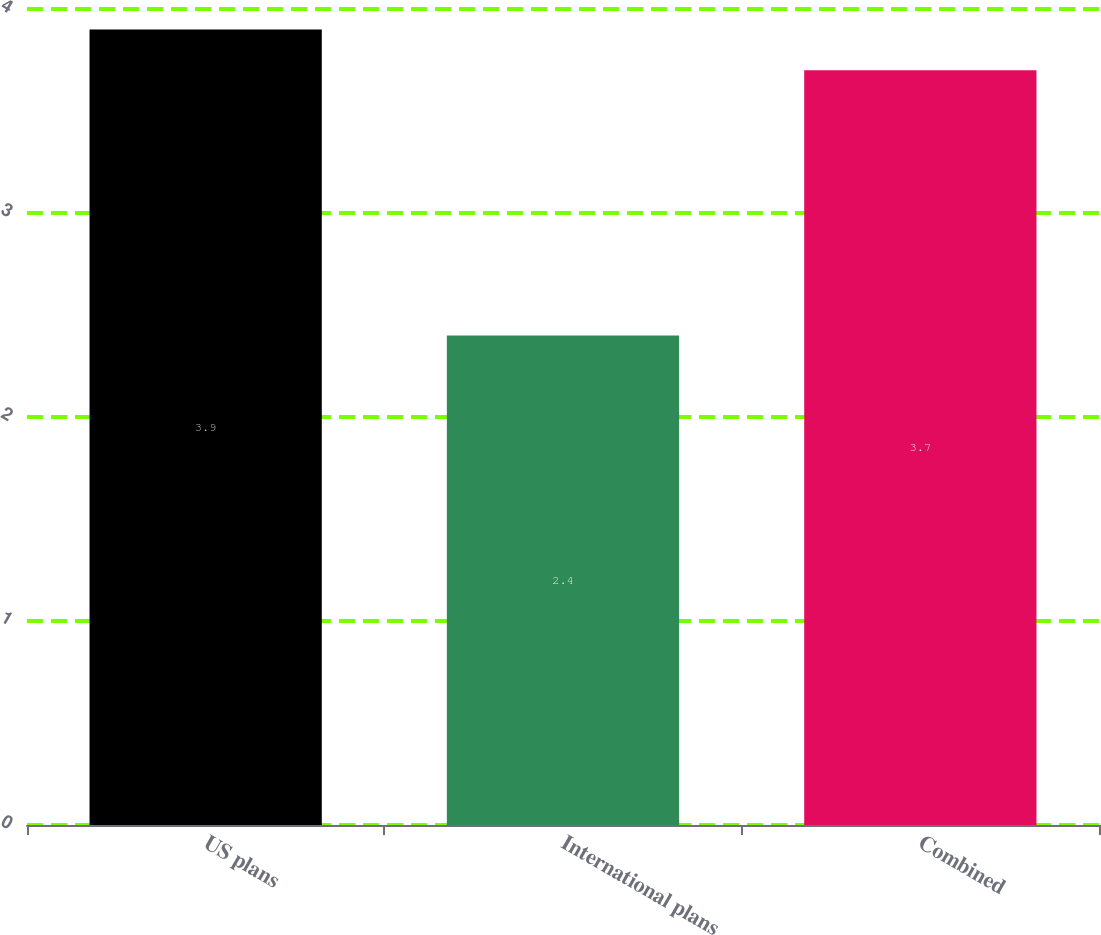Convert chart to OTSL. <chart><loc_0><loc_0><loc_500><loc_500><bar_chart><fcel>US plans<fcel>International plans<fcel>Combined<nl><fcel>3.9<fcel>2.4<fcel>3.7<nl></chart> 